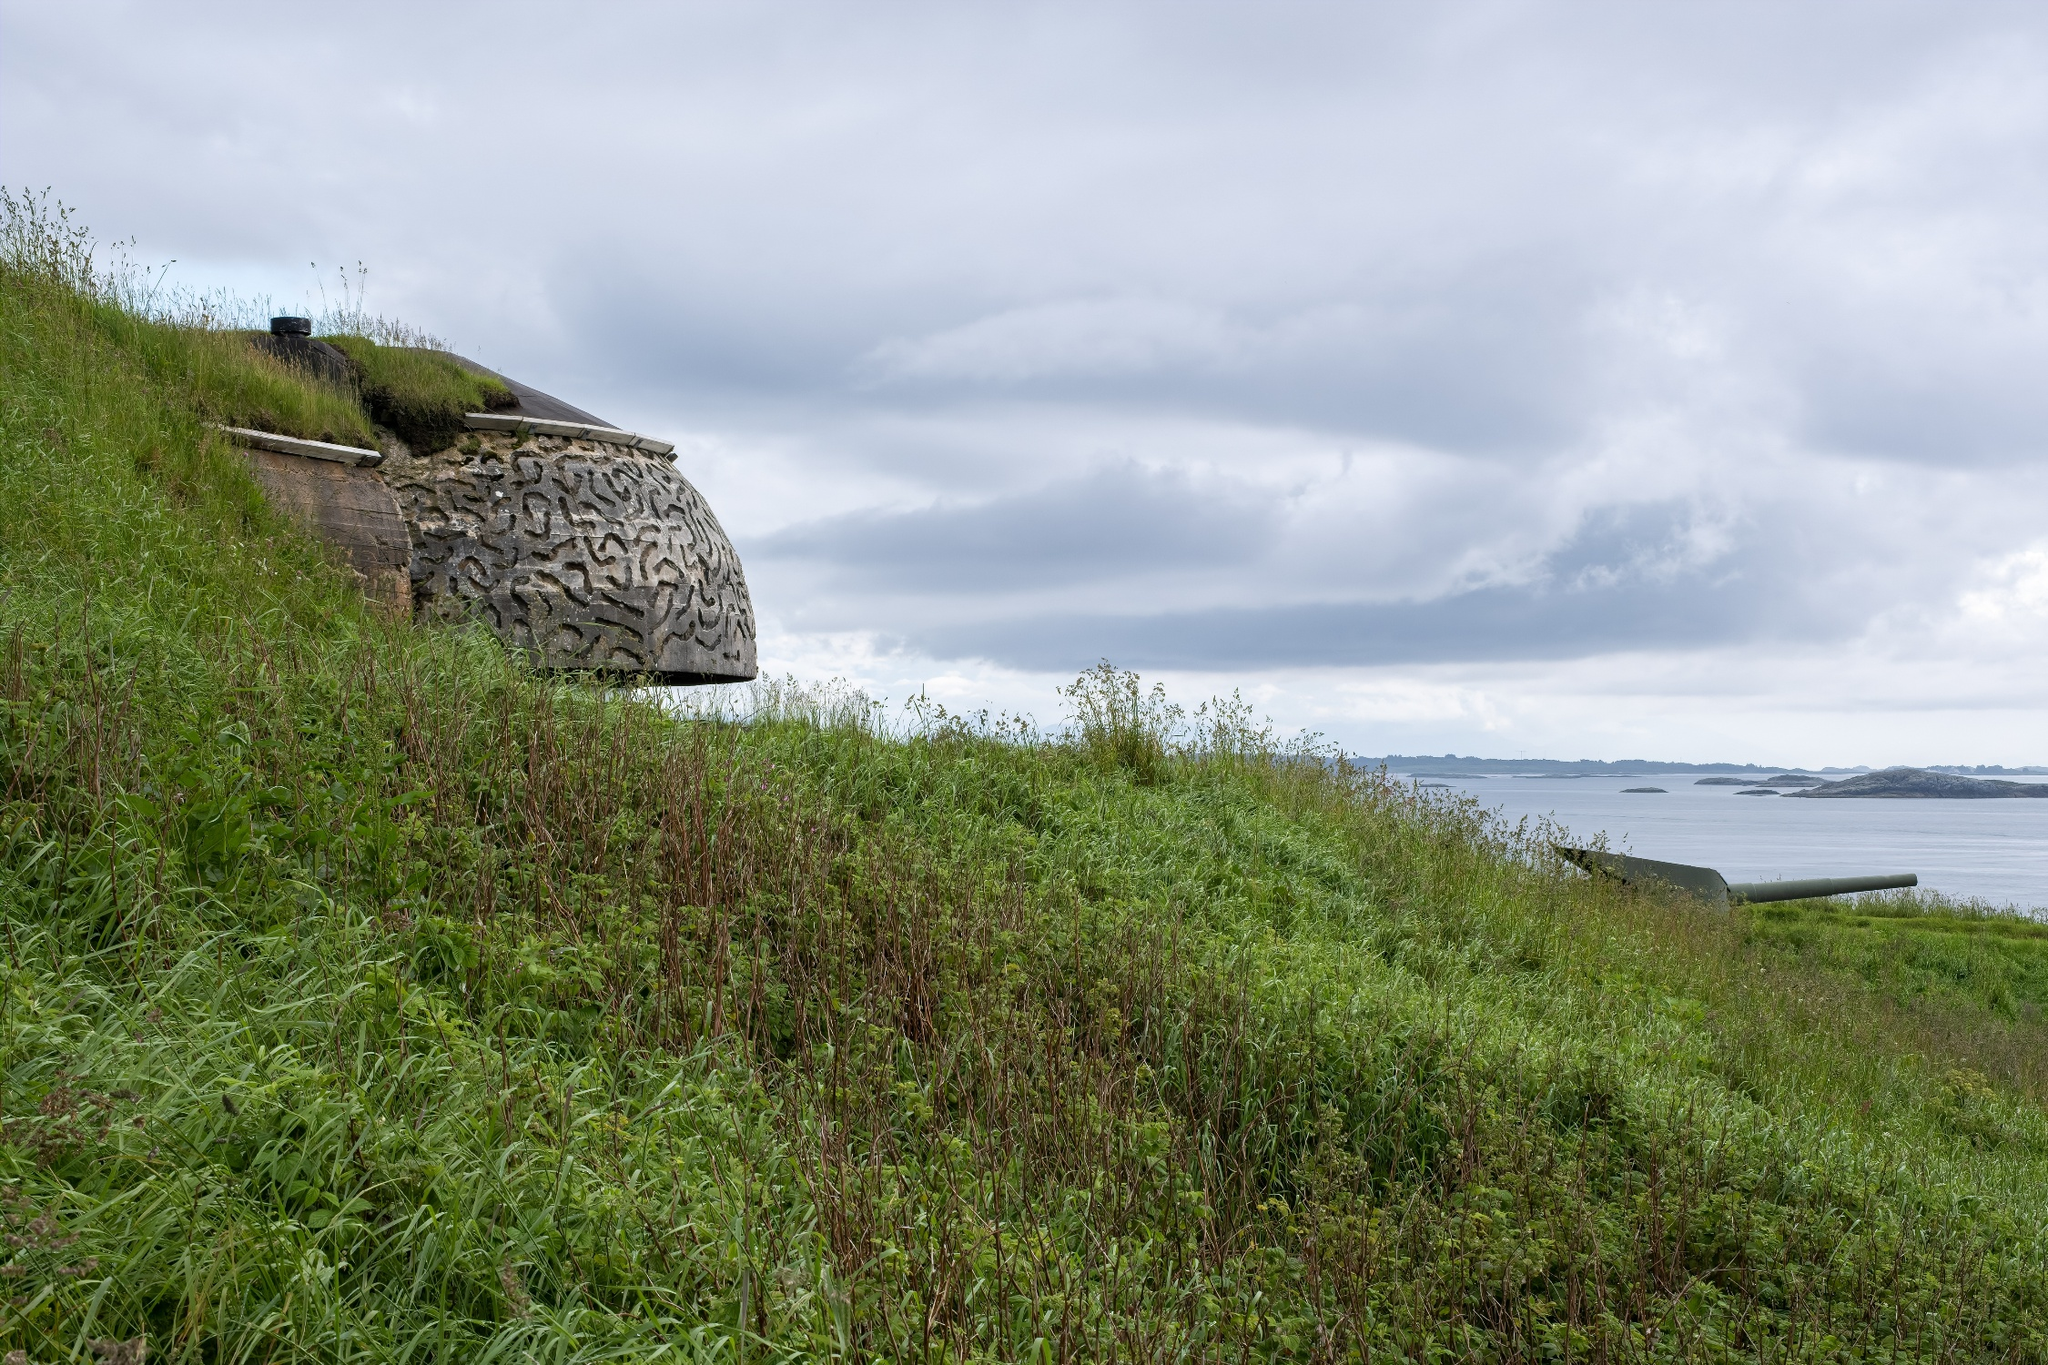What are the key elements in this picture? The image beautifully captures a tranquil landscape. On the left side, there is a stone bunker adorned with a distinct pattern of interlocking lines, creating an intricate texture. A small window is positioned on the left side of the bunker, allowing for a peek into its interior. The structure is set on a lush green hillside, blanketed with grass and sporadic shrubs, giving a sense of natural beauty. The hill gently slopes down towards the expansive ocean, which stretches out into the horizon. Above, the sky is filled with a dynamic array of clouds that add depth to the scene. The photograph appears to be taken from an elevated vantage point, offering a panoramic view of the combined elements – the bunker, the greenery, and the vast ocean, all coexisting in harmony and exuding a serene, peaceful ambiance. 